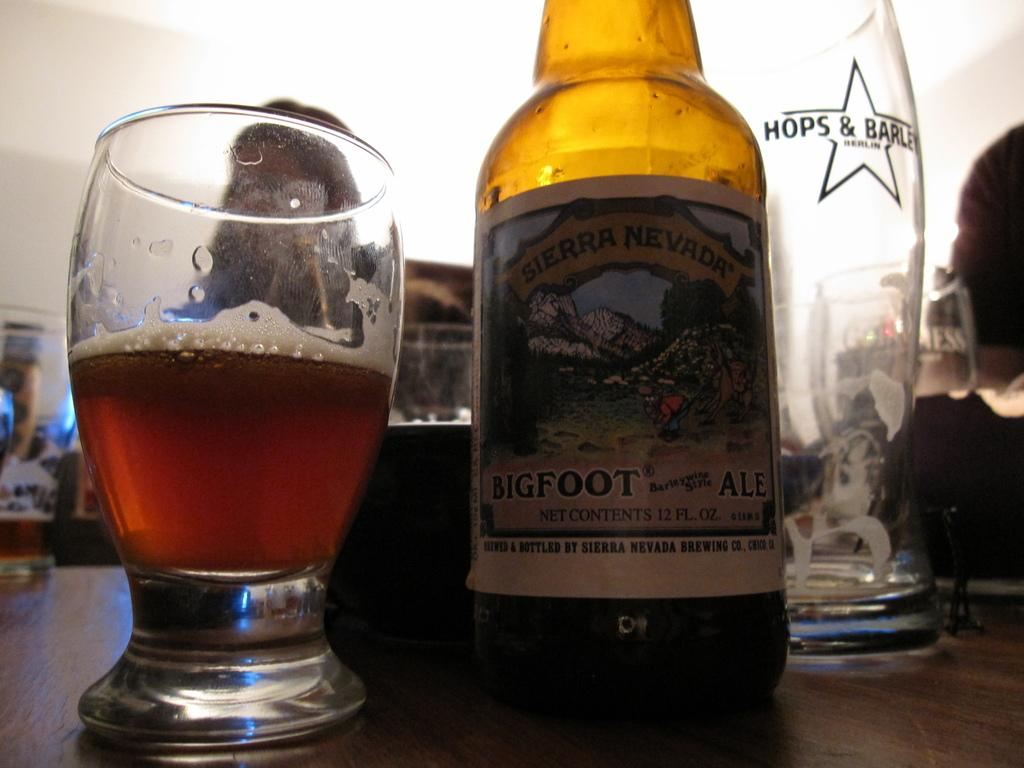What type of beverage container is present in the image? There is a beer bottle in the image. What else can be seen in the image besides the beer bottle? There are glasses in the image. Where are the glasses and beer bottle placed? The glasses and beer bottle are placed on a wooden board. What is in one of the glasses? One of the glasses contains alcohol. What historical event is depicted in the image? There is no historical event depicted in the image; it features a beer bottle, glasses, and a wooden board. Can you see a hook in the image? There is no hook present in the image. 